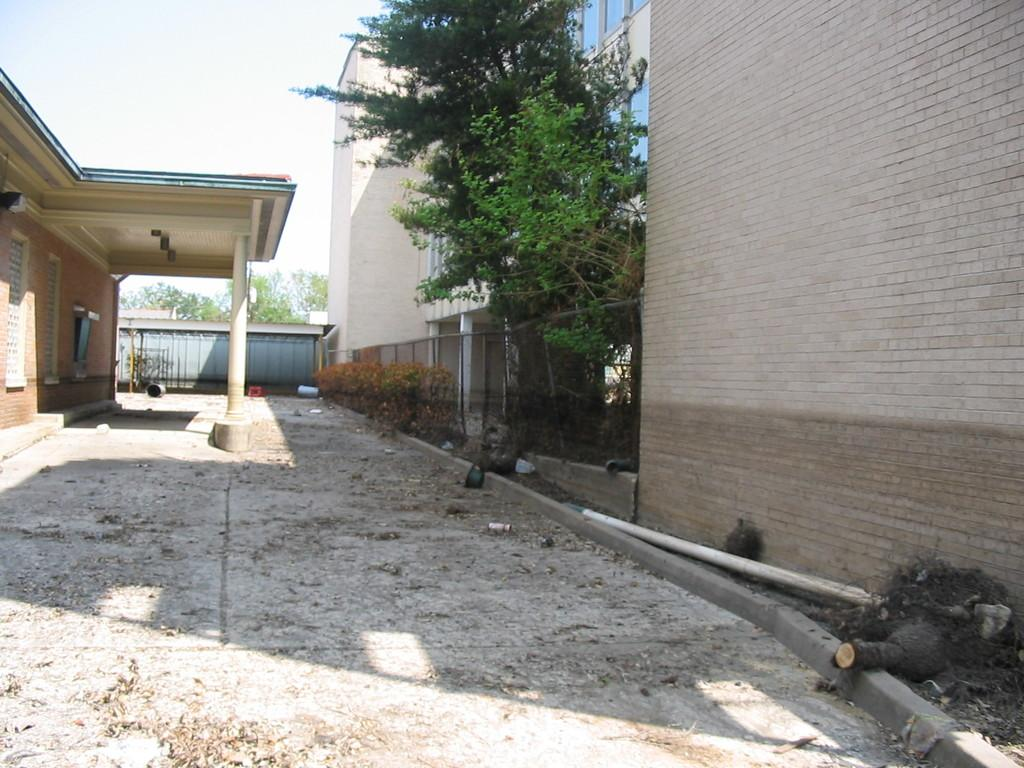What can be seen on both sides of the image? There are houses on both the right and left sides of the image. What type of vegetation is visible at the top of the image? There are trees at the top side of the image. What is the purpose of the net boundary in the image? The net boundary's purpose is not specified in the facts, but it could be for sports or separating areas. Where is the pet sitting on the desk in the image? There is no pet or desk present in the image. 